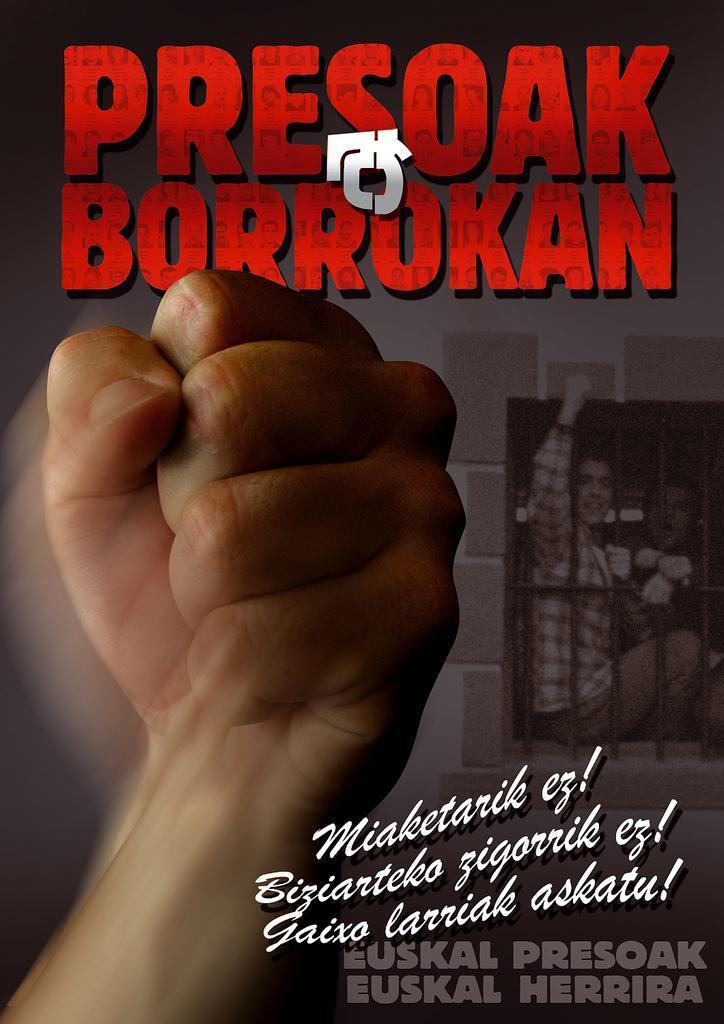In one or two sentences, can you explain what this image depicts? In this picture we can see person hand and poster, in this poster we can see people, window and something written on this. 